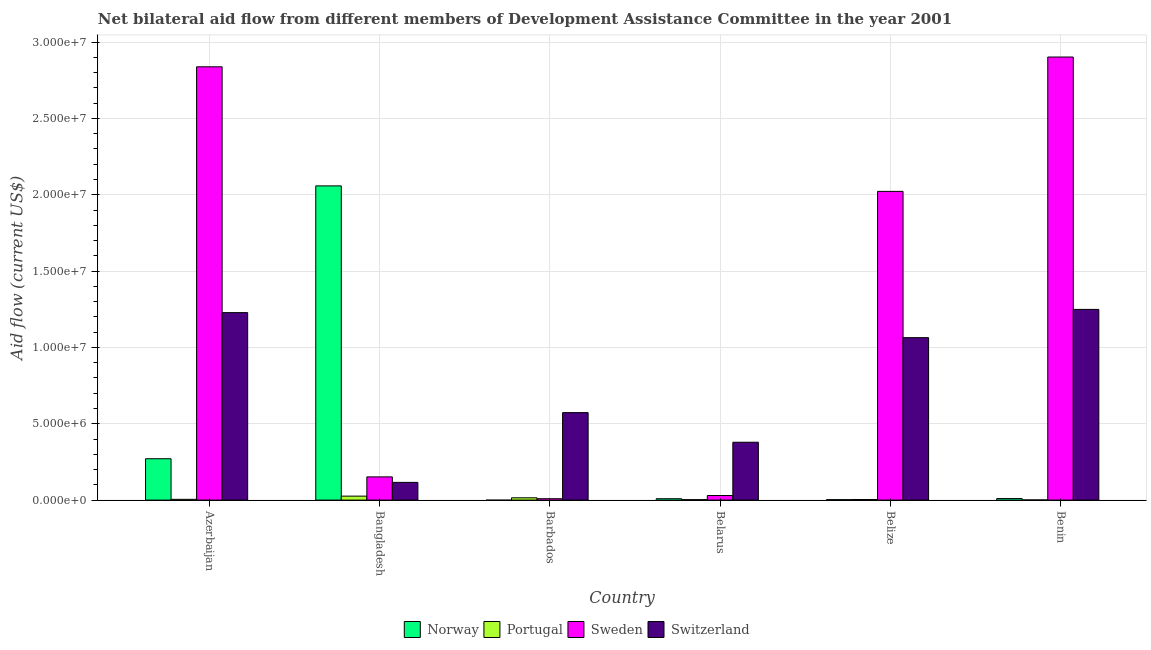How many groups of bars are there?
Keep it short and to the point. 6. Are the number of bars on each tick of the X-axis equal?
Make the answer very short. No. What is the label of the 2nd group of bars from the left?
Provide a short and direct response. Bangladesh. What is the amount of aid given by portugal in Belarus?
Provide a succinct answer. 3.00e+04. Across all countries, what is the maximum amount of aid given by sweden?
Offer a terse response. 2.90e+07. Across all countries, what is the minimum amount of aid given by norway?
Your response must be concise. 0. In which country was the amount of aid given by norway maximum?
Your answer should be compact. Bangladesh. What is the total amount of aid given by sweden in the graph?
Offer a terse response. 7.95e+07. What is the difference between the amount of aid given by portugal in Azerbaijan and that in Barbados?
Keep it short and to the point. -1.00e+05. What is the difference between the amount of aid given by sweden in Bangladesh and the amount of aid given by switzerland in Belarus?
Give a very brief answer. -2.27e+06. What is the average amount of aid given by portugal per country?
Keep it short and to the point. 9.00e+04. What is the difference between the amount of aid given by norway and amount of aid given by switzerland in Belarus?
Offer a terse response. -3.70e+06. In how many countries, is the amount of aid given by norway greater than 26000000 US$?
Your response must be concise. 0. What is the ratio of the amount of aid given by switzerland in Belarus to that in Belize?
Give a very brief answer. 0.36. What is the difference between the highest and the second highest amount of aid given by norway?
Give a very brief answer. 1.79e+07. What is the difference between the highest and the lowest amount of aid given by portugal?
Offer a terse response. 2.50e+05. Is the sum of the amount of aid given by switzerland in Azerbaijan and Benin greater than the maximum amount of aid given by portugal across all countries?
Your answer should be compact. Yes. Is it the case that in every country, the sum of the amount of aid given by norway and amount of aid given by sweden is greater than the sum of amount of aid given by portugal and amount of aid given by switzerland?
Your response must be concise. No. Is it the case that in every country, the sum of the amount of aid given by norway and amount of aid given by portugal is greater than the amount of aid given by sweden?
Your answer should be compact. No. Are all the bars in the graph horizontal?
Your answer should be compact. No. What is the difference between two consecutive major ticks on the Y-axis?
Give a very brief answer. 5.00e+06. Are the values on the major ticks of Y-axis written in scientific E-notation?
Offer a terse response. Yes. Does the graph contain any zero values?
Give a very brief answer. Yes. Does the graph contain grids?
Ensure brevity in your answer.  Yes. Where does the legend appear in the graph?
Provide a succinct answer. Bottom center. How are the legend labels stacked?
Offer a very short reply. Horizontal. What is the title of the graph?
Offer a terse response. Net bilateral aid flow from different members of Development Assistance Committee in the year 2001. Does "SF6 gas" appear as one of the legend labels in the graph?
Your answer should be compact. No. What is the label or title of the Y-axis?
Make the answer very short. Aid flow (current US$). What is the Aid flow (current US$) of Norway in Azerbaijan?
Keep it short and to the point. 2.71e+06. What is the Aid flow (current US$) in Portugal in Azerbaijan?
Your response must be concise. 5.00e+04. What is the Aid flow (current US$) in Sweden in Azerbaijan?
Offer a terse response. 2.84e+07. What is the Aid flow (current US$) of Switzerland in Azerbaijan?
Your answer should be very brief. 1.23e+07. What is the Aid flow (current US$) of Norway in Bangladesh?
Offer a terse response. 2.06e+07. What is the Aid flow (current US$) of Portugal in Bangladesh?
Ensure brevity in your answer.  2.60e+05. What is the Aid flow (current US$) in Sweden in Bangladesh?
Offer a terse response. 1.52e+06. What is the Aid flow (current US$) in Switzerland in Bangladesh?
Your answer should be compact. 1.16e+06. What is the Aid flow (current US$) in Norway in Barbados?
Offer a terse response. 0. What is the Aid flow (current US$) of Sweden in Barbados?
Make the answer very short. 9.00e+04. What is the Aid flow (current US$) in Switzerland in Barbados?
Ensure brevity in your answer.  5.73e+06. What is the Aid flow (current US$) in Sweden in Belarus?
Keep it short and to the point. 3.00e+05. What is the Aid flow (current US$) in Switzerland in Belarus?
Give a very brief answer. 3.79e+06. What is the Aid flow (current US$) in Portugal in Belize?
Keep it short and to the point. 4.00e+04. What is the Aid flow (current US$) of Sweden in Belize?
Make the answer very short. 2.02e+07. What is the Aid flow (current US$) in Switzerland in Belize?
Provide a succinct answer. 1.06e+07. What is the Aid flow (current US$) in Portugal in Benin?
Provide a short and direct response. 10000. What is the Aid flow (current US$) of Sweden in Benin?
Offer a very short reply. 2.90e+07. What is the Aid flow (current US$) in Switzerland in Benin?
Your response must be concise. 1.25e+07. Across all countries, what is the maximum Aid flow (current US$) in Norway?
Offer a very short reply. 2.06e+07. Across all countries, what is the maximum Aid flow (current US$) in Sweden?
Offer a very short reply. 2.90e+07. Across all countries, what is the maximum Aid flow (current US$) of Switzerland?
Give a very brief answer. 1.25e+07. Across all countries, what is the minimum Aid flow (current US$) in Portugal?
Ensure brevity in your answer.  10000. Across all countries, what is the minimum Aid flow (current US$) of Switzerland?
Your response must be concise. 1.16e+06. What is the total Aid flow (current US$) in Norway in the graph?
Keep it short and to the point. 2.35e+07. What is the total Aid flow (current US$) of Portugal in the graph?
Your response must be concise. 5.40e+05. What is the total Aid flow (current US$) of Sweden in the graph?
Give a very brief answer. 7.95e+07. What is the total Aid flow (current US$) in Switzerland in the graph?
Offer a very short reply. 4.61e+07. What is the difference between the Aid flow (current US$) in Norway in Azerbaijan and that in Bangladesh?
Make the answer very short. -1.79e+07. What is the difference between the Aid flow (current US$) in Portugal in Azerbaijan and that in Bangladesh?
Give a very brief answer. -2.10e+05. What is the difference between the Aid flow (current US$) of Sweden in Azerbaijan and that in Bangladesh?
Offer a terse response. 2.69e+07. What is the difference between the Aid flow (current US$) in Switzerland in Azerbaijan and that in Bangladesh?
Keep it short and to the point. 1.11e+07. What is the difference between the Aid flow (current US$) in Portugal in Azerbaijan and that in Barbados?
Make the answer very short. -1.00e+05. What is the difference between the Aid flow (current US$) of Sweden in Azerbaijan and that in Barbados?
Your answer should be very brief. 2.83e+07. What is the difference between the Aid flow (current US$) of Switzerland in Azerbaijan and that in Barbados?
Ensure brevity in your answer.  6.55e+06. What is the difference between the Aid flow (current US$) of Norway in Azerbaijan and that in Belarus?
Offer a terse response. 2.62e+06. What is the difference between the Aid flow (current US$) in Portugal in Azerbaijan and that in Belarus?
Offer a terse response. 2.00e+04. What is the difference between the Aid flow (current US$) of Sweden in Azerbaijan and that in Belarus?
Give a very brief answer. 2.81e+07. What is the difference between the Aid flow (current US$) in Switzerland in Azerbaijan and that in Belarus?
Provide a short and direct response. 8.49e+06. What is the difference between the Aid flow (current US$) in Norway in Azerbaijan and that in Belize?
Your answer should be compact. 2.68e+06. What is the difference between the Aid flow (current US$) in Sweden in Azerbaijan and that in Belize?
Keep it short and to the point. 8.16e+06. What is the difference between the Aid flow (current US$) in Switzerland in Azerbaijan and that in Belize?
Offer a very short reply. 1.64e+06. What is the difference between the Aid flow (current US$) in Norway in Azerbaijan and that in Benin?
Ensure brevity in your answer.  2.61e+06. What is the difference between the Aid flow (current US$) in Sweden in Azerbaijan and that in Benin?
Your answer should be very brief. -6.40e+05. What is the difference between the Aid flow (current US$) in Sweden in Bangladesh and that in Barbados?
Provide a succinct answer. 1.43e+06. What is the difference between the Aid flow (current US$) in Switzerland in Bangladesh and that in Barbados?
Provide a succinct answer. -4.57e+06. What is the difference between the Aid flow (current US$) in Norway in Bangladesh and that in Belarus?
Your answer should be very brief. 2.05e+07. What is the difference between the Aid flow (current US$) of Sweden in Bangladesh and that in Belarus?
Offer a very short reply. 1.22e+06. What is the difference between the Aid flow (current US$) in Switzerland in Bangladesh and that in Belarus?
Offer a very short reply. -2.63e+06. What is the difference between the Aid flow (current US$) in Norway in Bangladesh and that in Belize?
Ensure brevity in your answer.  2.06e+07. What is the difference between the Aid flow (current US$) of Sweden in Bangladesh and that in Belize?
Ensure brevity in your answer.  -1.87e+07. What is the difference between the Aid flow (current US$) in Switzerland in Bangladesh and that in Belize?
Your answer should be very brief. -9.48e+06. What is the difference between the Aid flow (current US$) of Norway in Bangladesh and that in Benin?
Offer a very short reply. 2.05e+07. What is the difference between the Aid flow (current US$) of Portugal in Bangladesh and that in Benin?
Keep it short and to the point. 2.50e+05. What is the difference between the Aid flow (current US$) in Sweden in Bangladesh and that in Benin?
Provide a short and direct response. -2.75e+07. What is the difference between the Aid flow (current US$) of Switzerland in Bangladesh and that in Benin?
Make the answer very short. -1.13e+07. What is the difference between the Aid flow (current US$) of Portugal in Barbados and that in Belarus?
Make the answer very short. 1.20e+05. What is the difference between the Aid flow (current US$) in Switzerland in Barbados and that in Belarus?
Offer a terse response. 1.94e+06. What is the difference between the Aid flow (current US$) of Sweden in Barbados and that in Belize?
Offer a terse response. -2.01e+07. What is the difference between the Aid flow (current US$) of Switzerland in Barbados and that in Belize?
Keep it short and to the point. -4.91e+06. What is the difference between the Aid flow (current US$) in Portugal in Barbados and that in Benin?
Offer a very short reply. 1.40e+05. What is the difference between the Aid flow (current US$) in Sweden in Barbados and that in Benin?
Provide a short and direct response. -2.89e+07. What is the difference between the Aid flow (current US$) of Switzerland in Barbados and that in Benin?
Provide a succinct answer. -6.76e+06. What is the difference between the Aid flow (current US$) of Norway in Belarus and that in Belize?
Offer a terse response. 6.00e+04. What is the difference between the Aid flow (current US$) in Portugal in Belarus and that in Belize?
Your answer should be compact. -10000. What is the difference between the Aid flow (current US$) of Sweden in Belarus and that in Belize?
Your answer should be compact. -1.99e+07. What is the difference between the Aid flow (current US$) in Switzerland in Belarus and that in Belize?
Offer a very short reply. -6.85e+06. What is the difference between the Aid flow (current US$) of Norway in Belarus and that in Benin?
Make the answer very short. -10000. What is the difference between the Aid flow (current US$) in Sweden in Belarus and that in Benin?
Provide a short and direct response. -2.87e+07. What is the difference between the Aid flow (current US$) of Switzerland in Belarus and that in Benin?
Your answer should be very brief. -8.70e+06. What is the difference between the Aid flow (current US$) in Norway in Belize and that in Benin?
Keep it short and to the point. -7.00e+04. What is the difference between the Aid flow (current US$) in Portugal in Belize and that in Benin?
Ensure brevity in your answer.  3.00e+04. What is the difference between the Aid flow (current US$) of Sweden in Belize and that in Benin?
Your answer should be compact. -8.80e+06. What is the difference between the Aid flow (current US$) in Switzerland in Belize and that in Benin?
Make the answer very short. -1.85e+06. What is the difference between the Aid flow (current US$) in Norway in Azerbaijan and the Aid flow (current US$) in Portugal in Bangladesh?
Keep it short and to the point. 2.45e+06. What is the difference between the Aid flow (current US$) of Norway in Azerbaijan and the Aid flow (current US$) of Sweden in Bangladesh?
Ensure brevity in your answer.  1.19e+06. What is the difference between the Aid flow (current US$) in Norway in Azerbaijan and the Aid flow (current US$) in Switzerland in Bangladesh?
Your response must be concise. 1.55e+06. What is the difference between the Aid flow (current US$) of Portugal in Azerbaijan and the Aid flow (current US$) of Sweden in Bangladesh?
Ensure brevity in your answer.  -1.47e+06. What is the difference between the Aid flow (current US$) in Portugal in Azerbaijan and the Aid flow (current US$) in Switzerland in Bangladesh?
Ensure brevity in your answer.  -1.11e+06. What is the difference between the Aid flow (current US$) in Sweden in Azerbaijan and the Aid flow (current US$) in Switzerland in Bangladesh?
Offer a terse response. 2.72e+07. What is the difference between the Aid flow (current US$) in Norway in Azerbaijan and the Aid flow (current US$) in Portugal in Barbados?
Provide a succinct answer. 2.56e+06. What is the difference between the Aid flow (current US$) in Norway in Azerbaijan and the Aid flow (current US$) in Sweden in Barbados?
Provide a succinct answer. 2.62e+06. What is the difference between the Aid flow (current US$) in Norway in Azerbaijan and the Aid flow (current US$) in Switzerland in Barbados?
Provide a succinct answer. -3.02e+06. What is the difference between the Aid flow (current US$) of Portugal in Azerbaijan and the Aid flow (current US$) of Sweden in Barbados?
Offer a terse response. -4.00e+04. What is the difference between the Aid flow (current US$) in Portugal in Azerbaijan and the Aid flow (current US$) in Switzerland in Barbados?
Keep it short and to the point. -5.68e+06. What is the difference between the Aid flow (current US$) in Sweden in Azerbaijan and the Aid flow (current US$) in Switzerland in Barbados?
Provide a succinct answer. 2.26e+07. What is the difference between the Aid flow (current US$) in Norway in Azerbaijan and the Aid flow (current US$) in Portugal in Belarus?
Keep it short and to the point. 2.68e+06. What is the difference between the Aid flow (current US$) of Norway in Azerbaijan and the Aid flow (current US$) of Sweden in Belarus?
Give a very brief answer. 2.41e+06. What is the difference between the Aid flow (current US$) of Norway in Azerbaijan and the Aid flow (current US$) of Switzerland in Belarus?
Keep it short and to the point. -1.08e+06. What is the difference between the Aid flow (current US$) in Portugal in Azerbaijan and the Aid flow (current US$) in Sweden in Belarus?
Give a very brief answer. -2.50e+05. What is the difference between the Aid flow (current US$) of Portugal in Azerbaijan and the Aid flow (current US$) of Switzerland in Belarus?
Give a very brief answer. -3.74e+06. What is the difference between the Aid flow (current US$) of Sweden in Azerbaijan and the Aid flow (current US$) of Switzerland in Belarus?
Your answer should be very brief. 2.46e+07. What is the difference between the Aid flow (current US$) in Norway in Azerbaijan and the Aid flow (current US$) in Portugal in Belize?
Provide a short and direct response. 2.67e+06. What is the difference between the Aid flow (current US$) in Norway in Azerbaijan and the Aid flow (current US$) in Sweden in Belize?
Your response must be concise. -1.75e+07. What is the difference between the Aid flow (current US$) of Norway in Azerbaijan and the Aid flow (current US$) of Switzerland in Belize?
Make the answer very short. -7.93e+06. What is the difference between the Aid flow (current US$) of Portugal in Azerbaijan and the Aid flow (current US$) of Sweden in Belize?
Ensure brevity in your answer.  -2.02e+07. What is the difference between the Aid flow (current US$) of Portugal in Azerbaijan and the Aid flow (current US$) of Switzerland in Belize?
Offer a terse response. -1.06e+07. What is the difference between the Aid flow (current US$) in Sweden in Azerbaijan and the Aid flow (current US$) in Switzerland in Belize?
Your answer should be very brief. 1.77e+07. What is the difference between the Aid flow (current US$) of Norway in Azerbaijan and the Aid flow (current US$) of Portugal in Benin?
Make the answer very short. 2.70e+06. What is the difference between the Aid flow (current US$) in Norway in Azerbaijan and the Aid flow (current US$) in Sweden in Benin?
Your answer should be compact. -2.63e+07. What is the difference between the Aid flow (current US$) of Norway in Azerbaijan and the Aid flow (current US$) of Switzerland in Benin?
Keep it short and to the point. -9.78e+06. What is the difference between the Aid flow (current US$) of Portugal in Azerbaijan and the Aid flow (current US$) of Sweden in Benin?
Offer a terse response. -2.90e+07. What is the difference between the Aid flow (current US$) in Portugal in Azerbaijan and the Aid flow (current US$) in Switzerland in Benin?
Give a very brief answer. -1.24e+07. What is the difference between the Aid flow (current US$) in Sweden in Azerbaijan and the Aid flow (current US$) in Switzerland in Benin?
Your response must be concise. 1.59e+07. What is the difference between the Aid flow (current US$) in Norway in Bangladesh and the Aid flow (current US$) in Portugal in Barbados?
Make the answer very short. 2.04e+07. What is the difference between the Aid flow (current US$) in Norway in Bangladesh and the Aid flow (current US$) in Sweden in Barbados?
Offer a terse response. 2.05e+07. What is the difference between the Aid flow (current US$) in Norway in Bangladesh and the Aid flow (current US$) in Switzerland in Barbados?
Keep it short and to the point. 1.48e+07. What is the difference between the Aid flow (current US$) of Portugal in Bangladesh and the Aid flow (current US$) of Switzerland in Barbados?
Make the answer very short. -5.47e+06. What is the difference between the Aid flow (current US$) of Sweden in Bangladesh and the Aid flow (current US$) of Switzerland in Barbados?
Ensure brevity in your answer.  -4.21e+06. What is the difference between the Aid flow (current US$) of Norway in Bangladesh and the Aid flow (current US$) of Portugal in Belarus?
Make the answer very short. 2.06e+07. What is the difference between the Aid flow (current US$) of Norway in Bangladesh and the Aid flow (current US$) of Sweden in Belarus?
Your response must be concise. 2.03e+07. What is the difference between the Aid flow (current US$) of Norway in Bangladesh and the Aid flow (current US$) of Switzerland in Belarus?
Ensure brevity in your answer.  1.68e+07. What is the difference between the Aid flow (current US$) in Portugal in Bangladesh and the Aid flow (current US$) in Sweden in Belarus?
Provide a short and direct response. -4.00e+04. What is the difference between the Aid flow (current US$) in Portugal in Bangladesh and the Aid flow (current US$) in Switzerland in Belarus?
Your answer should be compact. -3.53e+06. What is the difference between the Aid flow (current US$) in Sweden in Bangladesh and the Aid flow (current US$) in Switzerland in Belarus?
Keep it short and to the point. -2.27e+06. What is the difference between the Aid flow (current US$) of Norway in Bangladesh and the Aid flow (current US$) of Portugal in Belize?
Provide a short and direct response. 2.05e+07. What is the difference between the Aid flow (current US$) of Norway in Bangladesh and the Aid flow (current US$) of Switzerland in Belize?
Provide a short and direct response. 9.94e+06. What is the difference between the Aid flow (current US$) of Portugal in Bangladesh and the Aid flow (current US$) of Sweden in Belize?
Provide a succinct answer. -2.00e+07. What is the difference between the Aid flow (current US$) in Portugal in Bangladesh and the Aid flow (current US$) in Switzerland in Belize?
Offer a terse response. -1.04e+07. What is the difference between the Aid flow (current US$) in Sweden in Bangladesh and the Aid flow (current US$) in Switzerland in Belize?
Provide a succinct answer. -9.12e+06. What is the difference between the Aid flow (current US$) of Norway in Bangladesh and the Aid flow (current US$) of Portugal in Benin?
Your answer should be very brief. 2.06e+07. What is the difference between the Aid flow (current US$) of Norway in Bangladesh and the Aid flow (current US$) of Sweden in Benin?
Your answer should be compact. -8.44e+06. What is the difference between the Aid flow (current US$) of Norway in Bangladesh and the Aid flow (current US$) of Switzerland in Benin?
Your answer should be compact. 8.09e+06. What is the difference between the Aid flow (current US$) of Portugal in Bangladesh and the Aid flow (current US$) of Sweden in Benin?
Ensure brevity in your answer.  -2.88e+07. What is the difference between the Aid flow (current US$) of Portugal in Bangladesh and the Aid flow (current US$) of Switzerland in Benin?
Give a very brief answer. -1.22e+07. What is the difference between the Aid flow (current US$) in Sweden in Bangladesh and the Aid flow (current US$) in Switzerland in Benin?
Ensure brevity in your answer.  -1.10e+07. What is the difference between the Aid flow (current US$) in Portugal in Barbados and the Aid flow (current US$) in Sweden in Belarus?
Make the answer very short. -1.50e+05. What is the difference between the Aid flow (current US$) in Portugal in Barbados and the Aid flow (current US$) in Switzerland in Belarus?
Provide a short and direct response. -3.64e+06. What is the difference between the Aid flow (current US$) in Sweden in Barbados and the Aid flow (current US$) in Switzerland in Belarus?
Give a very brief answer. -3.70e+06. What is the difference between the Aid flow (current US$) of Portugal in Barbados and the Aid flow (current US$) of Sweden in Belize?
Your answer should be compact. -2.01e+07. What is the difference between the Aid flow (current US$) in Portugal in Barbados and the Aid flow (current US$) in Switzerland in Belize?
Your answer should be very brief. -1.05e+07. What is the difference between the Aid flow (current US$) of Sweden in Barbados and the Aid flow (current US$) of Switzerland in Belize?
Make the answer very short. -1.06e+07. What is the difference between the Aid flow (current US$) of Portugal in Barbados and the Aid flow (current US$) of Sweden in Benin?
Make the answer very short. -2.89e+07. What is the difference between the Aid flow (current US$) in Portugal in Barbados and the Aid flow (current US$) in Switzerland in Benin?
Your answer should be compact. -1.23e+07. What is the difference between the Aid flow (current US$) of Sweden in Barbados and the Aid flow (current US$) of Switzerland in Benin?
Ensure brevity in your answer.  -1.24e+07. What is the difference between the Aid flow (current US$) of Norway in Belarus and the Aid flow (current US$) of Portugal in Belize?
Offer a terse response. 5.00e+04. What is the difference between the Aid flow (current US$) of Norway in Belarus and the Aid flow (current US$) of Sweden in Belize?
Your response must be concise. -2.01e+07. What is the difference between the Aid flow (current US$) in Norway in Belarus and the Aid flow (current US$) in Switzerland in Belize?
Provide a succinct answer. -1.06e+07. What is the difference between the Aid flow (current US$) in Portugal in Belarus and the Aid flow (current US$) in Sweden in Belize?
Your response must be concise. -2.02e+07. What is the difference between the Aid flow (current US$) in Portugal in Belarus and the Aid flow (current US$) in Switzerland in Belize?
Your response must be concise. -1.06e+07. What is the difference between the Aid flow (current US$) in Sweden in Belarus and the Aid flow (current US$) in Switzerland in Belize?
Your answer should be very brief. -1.03e+07. What is the difference between the Aid flow (current US$) of Norway in Belarus and the Aid flow (current US$) of Portugal in Benin?
Ensure brevity in your answer.  8.00e+04. What is the difference between the Aid flow (current US$) in Norway in Belarus and the Aid flow (current US$) in Sweden in Benin?
Offer a very short reply. -2.89e+07. What is the difference between the Aid flow (current US$) of Norway in Belarus and the Aid flow (current US$) of Switzerland in Benin?
Your answer should be compact. -1.24e+07. What is the difference between the Aid flow (current US$) of Portugal in Belarus and the Aid flow (current US$) of Sweden in Benin?
Your answer should be very brief. -2.90e+07. What is the difference between the Aid flow (current US$) of Portugal in Belarus and the Aid flow (current US$) of Switzerland in Benin?
Give a very brief answer. -1.25e+07. What is the difference between the Aid flow (current US$) in Sweden in Belarus and the Aid flow (current US$) in Switzerland in Benin?
Provide a succinct answer. -1.22e+07. What is the difference between the Aid flow (current US$) in Norway in Belize and the Aid flow (current US$) in Portugal in Benin?
Give a very brief answer. 2.00e+04. What is the difference between the Aid flow (current US$) of Norway in Belize and the Aid flow (current US$) of Sweden in Benin?
Your answer should be compact. -2.90e+07. What is the difference between the Aid flow (current US$) of Norway in Belize and the Aid flow (current US$) of Switzerland in Benin?
Make the answer very short. -1.25e+07. What is the difference between the Aid flow (current US$) of Portugal in Belize and the Aid flow (current US$) of Sweden in Benin?
Your response must be concise. -2.90e+07. What is the difference between the Aid flow (current US$) of Portugal in Belize and the Aid flow (current US$) of Switzerland in Benin?
Your answer should be compact. -1.24e+07. What is the difference between the Aid flow (current US$) in Sweden in Belize and the Aid flow (current US$) in Switzerland in Benin?
Keep it short and to the point. 7.73e+06. What is the average Aid flow (current US$) of Norway per country?
Give a very brief answer. 3.92e+06. What is the average Aid flow (current US$) of Sweden per country?
Keep it short and to the point. 1.33e+07. What is the average Aid flow (current US$) in Switzerland per country?
Your answer should be compact. 7.68e+06. What is the difference between the Aid flow (current US$) in Norway and Aid flow (current US$) in Portugal in Azerbaijan?
Offer a very short reply. 2.66e+06. What is the difference between the Aid flow (current US$) of Norway and Aid flow (current US$) of Sweden in Azerbaijan?
Provide a short and direct response. -2.57e+07. What is the difference between the Aid flow (current US$) in Norway and Aid flow (current US$) in Switzerland in Azerbaijan?
Keep it short and to the point. -9.57e+06. What is the difference between the Aid flow (current US$) of Portugal and Aid flow (current US$) of Sweden in Azerbaijan?
Provide a short and direct response. -2.83e+07. What is the difference between the Aid flow (current US$) in Portugal and Aid flow (current US$) in Switzerland in Azerbaijan?
Offer a very short reply. -1.22e+07. What is the difference between the Aid flow (current US$) in Sweden and Aid flow (current US$) in Switzerland in Azerbaijan?
Offer a very short reply. 1.61e+07. What is the difference between the Aid flow (current US$) in Norway and Aid flow (current US$) in Portugal in Bangladesh?
Ensure brevity in your answer.  2.03e+07. What is the difference between the Aid flow (current US$) in Norway and Aid flow (current US$) in Sweden in Bangladesh?
Your answer should be compact. 1.91e+07. What is the difference between the Aid flow (current US$) in Norway and Aid flow (current US$) in Switzerland in Bangladesh?
Provide a short and direct response. 1.94e+07. What is the difference between the Aid flow (current US$) of Portugal and Aid flow (current US$) of Sweden in Bangladesh?
Keep it short and to the point. -1.26e+06. What is the difference between the Aid flow (current US$) in Portugal and Aid flow (current US$) in Switzerland in Bangladesh?
Offer a terse response. -9.00e+05. What is the difference between the Aid flow (current US$) of Sweden and Aid flow (current US$) of Switzerland in Bangladesh?
Offer a very short reply. 3.60e+05. What is the difference between the Aid flow (current US$) of Portugal and Aid flow (current US$) of Switzerland in Barbados?
Give a very brief answer. -5.58e+06. What is the difference between the Aid flow (current US$) in Sweden and Aid flow (current US$) in Switzerland in Barbados?
Give a very brief answer. -5.64e+06. What is the difference between the Aid flow (current US$) in Norway and Aid flow (current US$) in Portugal in Belarus?
Provide a succinct answer. 6.00e+04. What is the difference between the Aid flow (current US$) of Norway and Aid flow (current US$) of Sweden in Belarus?
Provide a short and direct response. -2.10e+05. What is the difference between the Aid flow (current US$) in Norway and Aid flow (current US$) in Switzerland in Belarus?
Provide a short and direct response. -3.70e+06. What is the difference between the Aid flow (current US$) in Portugal and Aid flow (current US$) in Sweden in Belarus?
Provide a succinct answer. -2.70e+05. What is the difference between the Aid flow (current US$) in Portugal and Aid flow (current US$) in Switzerland in Belarus?
Offer a terse response. -3.76e+06. What is the difference between the Aid flow (current US$) of Sweden and Aid flow (current US$) of Switzerland in Belarus?
Keep it short and to the point. -3.49e+06. What is the difference between the Aid flow (current US$) of Norway and Aid flow (current US$) of Sweden in Belize?
Your answer should be very brief. -2.02e+07. What is the difference between the Aid flow (current US$) in Norway and Aid flow (current US$) in Switzerland in Belize?
Ensure brevity in your answer.  -1.06e+07. What is the difference between the Aid flow (current US$) in Portugal and Aid flow (current US$) in Sweden in Belize?
Offer a very short reply. -2.02e+07. What is the difference between the Aid flow (current US$) in Portugal and Aid flow (current US$) in Switzerland in Belize?
Provide a succinct answer. -1.06e+07. What is the difference between the Aid flow (current US$) in Sweden and Aid flow (current US$) in Switzerland in Belize?
Your answer should be very brief. 9.58e+06. What is the difference between the Aid flow (current US$) in Norway and Aid flow (current US$) in Portugal in Benin?
Make the answer very short. 9.00e+04. What is the difference between the Aid flow (current US$) of Norway and Aid flow (current US$) of Sweden in Benin?
Keep it short and to the point. -2.89e+07. What is the difference between the Aid flow (current US$) of Norway and Aid flow (current US$) of Switzerland in Benin?
Ensure brevity in your answer.  -1.24e+07. What is the difference between the Aid flow (current US$) in Portugal and Aid flow (current US$) in Sweden in Benin?
Offer a terse response. -2.90e+07. What is the difference between the Aid flow (current US$) of Portugal and Aid flow (current US$) of Switzerland in Benin?
Make the answer very short. -1.25e+07. What is the difference between the Aid flow (current US$) of Sweden and Aid flow (current US$) of Switzerland in Benin?
Your response must be concise. 1.65e+07. What is the ratio of the Aid flow (current US$) in Norway in Azerbaijan to that in Bangladesh?
Offer a terse response. 0.13. What is the ratio of the Aid flow (current US$) of Portugal in Azerbaijan to that in Bangladesh?
Offer a very short reply. 0.19. What is the ratio of the Aid flow (current US$) in Sweden in Azerbaijan to that in Bangladesh?
Provide a short and direct response. 18.67. What is the ratio of the Aid flow (current US$) in Switzerland in Azerbaijan to that in Bangladesh?
Make the answer very short. 10.59. What is the ratio of the Aid flow (current US$) of Sweden in Azerbaijan to that in Barbados?
Your answer should be compact. 315.33. What is the ratio of the Aid flow (current US$) in Switzerland in Azerbaijan to that in Barbados?
Provide a short and direct response. 2.14. What is the ratio of the Aid flow (current US$) in Norway in Azerbaijan to that in Belarus?
Your answer should be very brief. 30.11. What is the ratio of the Aid flow (current US$) of Sweden in Azerbaijan to that in Belarus?
Provide a short and direct response. 94.6. What is the ratio of the Aid flow (current US$) in Switzerland in Azerbaijan to that in Belarus?
Provide a short and direct response. 3.24. What is the ratio of the Aid flow (current US$) in Norway in Azerbaijan to that in Belize?
Offer a very short reply. 90.33. What is the ratio of the Aid flow (current US$) of Sweden in Azerbaijan to that in Belize?
Your answer should be compact. 1.4. What is the ratio of the Aid flow (current US$) of Switzerland in Azerbaijan to that in Belize?
Offer a terse response. 1.15. What is the ratio of the Aid flow (current US$) of Norway in Azerbaijan to that in Benin?
Give a very brief answer. 27.1. What is the ratio of the Aid flow (current US$) in Sweden in Azerbaijan to that in Benin?
Provide a succinct answer. 0.98. What is the ratio of the Aid flow (current US$) of Switzerland in Azerbaijan to that in Benin?
Provide a succinct answer. 0.98. What is the ratio of the Aid flow (current US$) of Portugal in Bangladesh to that in Barbados?
Offer a terse response. 1.73. What is the ratio of the Aid flow (current US$) of Sweden in Bangladesh to that in Barbados?
Your answer should be very brief. 16.89. What is the ratio of the Aid flow (current US$) of Switzerland in Bangladesh to that in Barbados?
Your answer should be very brief. 0.2. What is the ratio of the Aid flow (current US$) in Norway in Bangladesh to that in Belarus?
Give a very brief answer. 228.67. What is the ratio of the Aid flow (current US$) in Portugal in Bangladesh to that in Belarus?
Offer a very short reply. 8.67. What is the ratio of the Aid flow (current US$) of Sweden in Bangladesh to that in Belarus?
Ensure brevity in your answer.  5.07. What is the ratio of the Aid flow (current US$) of Switzerland in Bangladesh to that in Belarus?
Offer a terse response. 0.31. What is the ratio of the Aid flow (current US$) of Norway in Bangladesh to that in Belize?
Your answer should be very brief. 686. What is the ratio of the Aid flow (current US$) in Sweden in Bangladesh to that in Belize?
Your answer should be very brief. 0.08. What is the ratio of the Aid flow (current US$) in Switzerland in Bangladesh to that in Belize?
Your response must be concise. 0.11. What is the ratio of the Aid flow (current US$) of Norway in Bangladesh to that in Benin?
Ensure brevity in your answer.  205.8. What is the ratio of the Aid flow (current US$) of Portugal in Bangladesh to that in Benin?
Make the answer very short. 26. What is the ratio of the Aid flow (current US$) of Sweden in Bangladesh to that in Benin?
Make the answer very short. 0.05. What is the ratio of the Aid flow (current US$) of Switzerland in Bangladesh to that in Benin?
Your response must be concise. 0.09. What is the ratio of the Aid flow (current US$) in Switzerland in Barbados to that in Belarus?
Your answer should be very brief. 1.51. What is the ratio of the Aid flow (current US$) in Portugal in Barbados to that in Belize?
Your answer should be compact. 3.75. What is the ratio of the Aid flow (current US$) of Sweden in Barbados to that in Belize?
Ensure brevity in your answer.  0. What is the ratio of the Aid flow (current US$) of Switzerland in Barbados to that in Belize?
Your answer should be very brief. 0.54. What is the ratio of the Aid flow (current US$) in Portugal in Barbados to that in Benin?
Provide a succinct answer. 15. What is the ratio of the Aid flow (current US$) in Sweden in Barbados to that in Benin?
Keep it short and to the point. 0. What is the ratio of the Aid flow (current US$) in Switzerland in Barbados to that in Benin?
Your answer should be very brief. 0.46. What is the ratio of the Aid flow (current US$) in Norway in Belarus to that in Belize?
Offer a terse response. 3. What is the ratio of the Aid flow (current US$) in Portugal in Belarus to that in Belize?
Your response must be concise. 0.75. What is the ratio of the Aid flow (current US$) of Sweden in Belarus to that in Belize?
Your answer should be compact. 0.01. What is the ratio of the Aid flow (current US$) of Switzerland in Belarus to that in Belize?
Provide a succinct answer. 0.36. What is the ratio of the Aid flow (current US$) in Norway in Belarus to that in Benin?
Provide a succinct answer. 0.9. What is the ratio of the Aid flow (current US$) of Portugal in Belarus to that in Benin?
Provide a short and direct response. 3. What is the ratio of the Aid flow (current US$) of Sweden in Belarus to that in Benin?
Offer a very short reply. 0.01. What is the ratio of the Aid flow (current US$) of Switzerland in Belarus to that in Benin?
Give a very brief answer. 0.3. What is the ratio of the Aid flow (current US$) of Portugal in Belize to that in Benin?
Your answer should be very brief. 4. What is the ratio of the Aid flow (current US$) of Sweden in Belize to that in Benin?
Make the answer very short. 0.7. What is the ratio of the Aid flow (current US$) of Switzerland in Belize to that in Benin?
Make the answer very short. 0.85. What is the difference between the highest and the second highest Aid flow (current US$) of Norway?
Your response must be concise. 1.79e+07. What is the difference between the highest and the second highest Aid flow (current US$) in Sweden?
Offer a terse response. 6.40e+05. What is the difference between the highest and the lowest Aid flow (current US$) in Norway?
Give a very brief answer. 2.06e+07. What is the difference between the highest and the lowest Aid flow (current US$) of Sweden?
Make the answer very short. 2.89e+07. What is the difference between the highest and the lowest Aid flow (current US$) in Switzerland?
Your answer should be compact. 1.13e+07. 